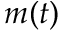<formula> <loc_0><loc_0><loc_500><loc_500>m ( t )</formula> 